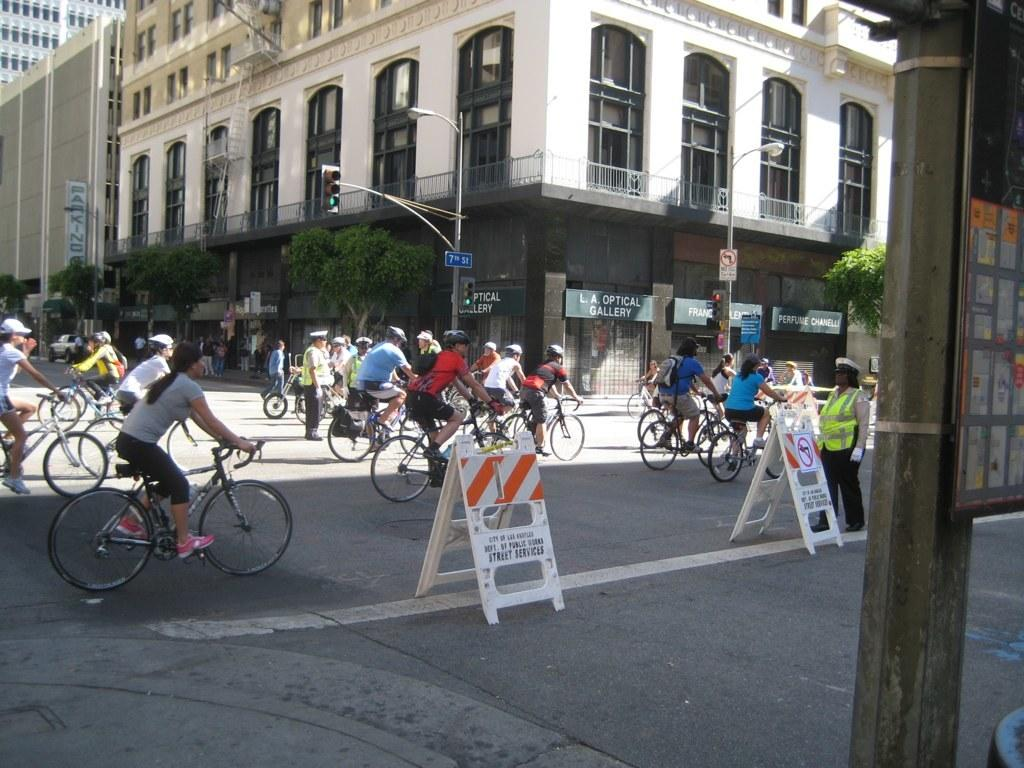Where was the image taken? The image was taken on a road. What are the people in the image doing? The people in the image are riding bicycles. What else can be seen in the background of the image? There is a vehicle and trees visible in the background of the image. What type of bead is being used as a decoration on the bicycles in the image? There is no bead present as a decoration on the bicycles in the image. What time does the minister arrive in the image? There is no minister present in the image. 